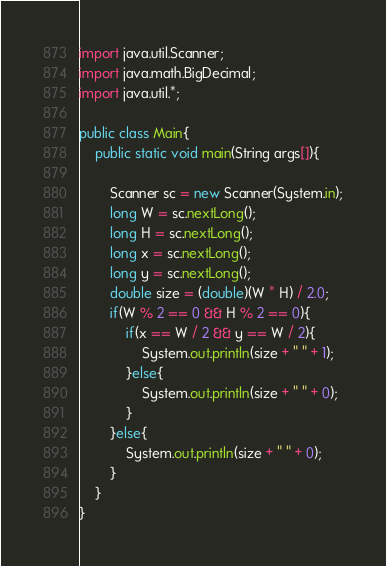<code> <loc_0><loc_0><loc_500><loc_500><_Java_>import java.util.Scanner;
import java.math.BigDecimal;
import java.util.*;

public class Main{
    public static void main(String args[]){
        
        Scanner sc = new Scanner(System.in);
        long W = sc.nextLong();
        long H = sc.nextLong();
        long x = sc.nextLong();
        long y = sc.nextLong();
        double size = (double)(W * H) / 2.0;
        if(W % 2 == 0 && H % 2 == 0){
            if(x == W / 2 && y == W / 2){
                System.out.println(size + " " + 1);
            }else{
                System.out.println(size + " " + 0);
            }
        }else{
            System.out.println(size + " " + 0);
        }
    }
}
</code> 